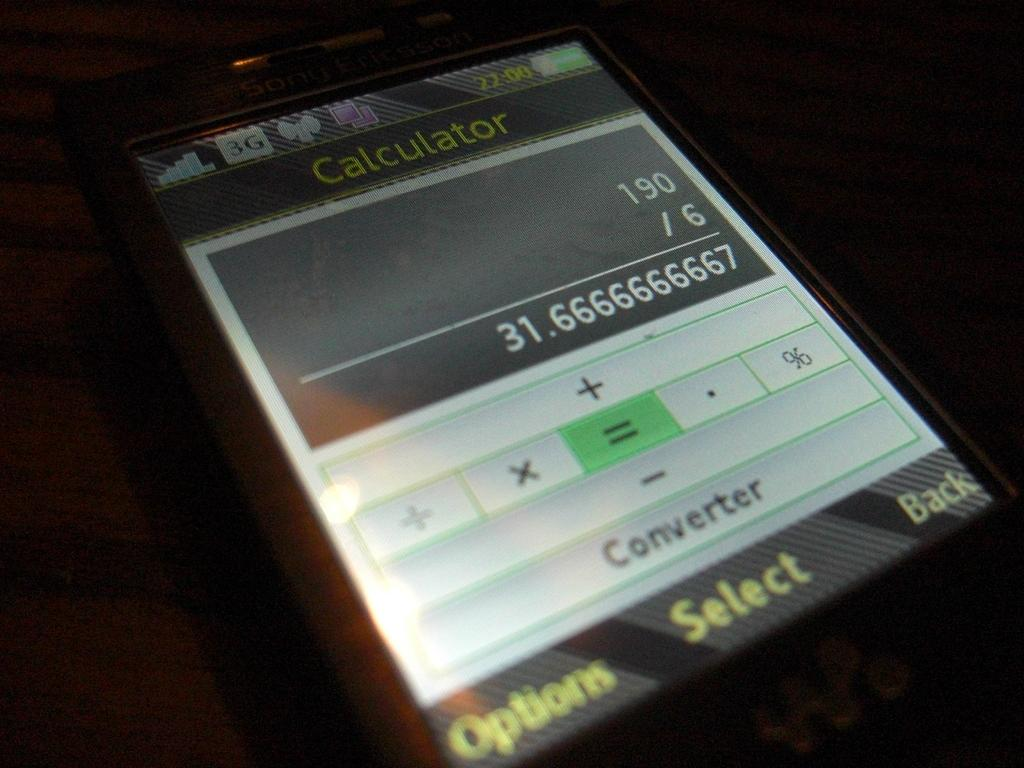<image>
Offer a succinct explanation of the picture presented. An electronic calculator is shown on a small screen with a division problem displayed. 